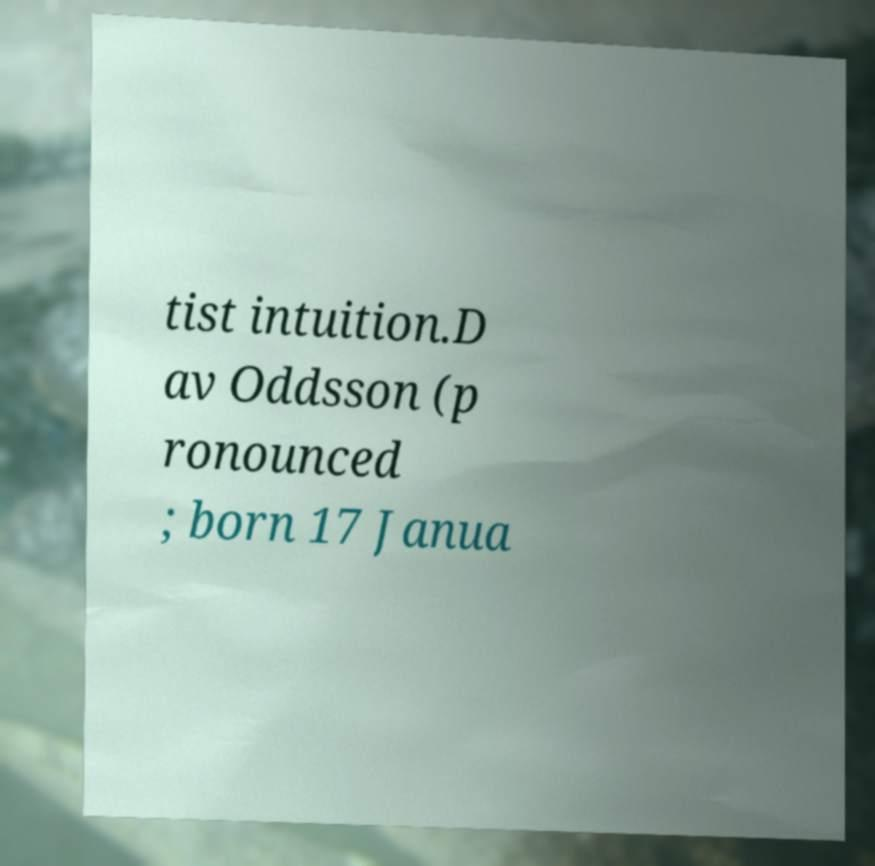Could you assist in decoding the text presented in this image and type it out clearly? tist intuition.D av Oddsson (p ronounced ; born 17 Janua 